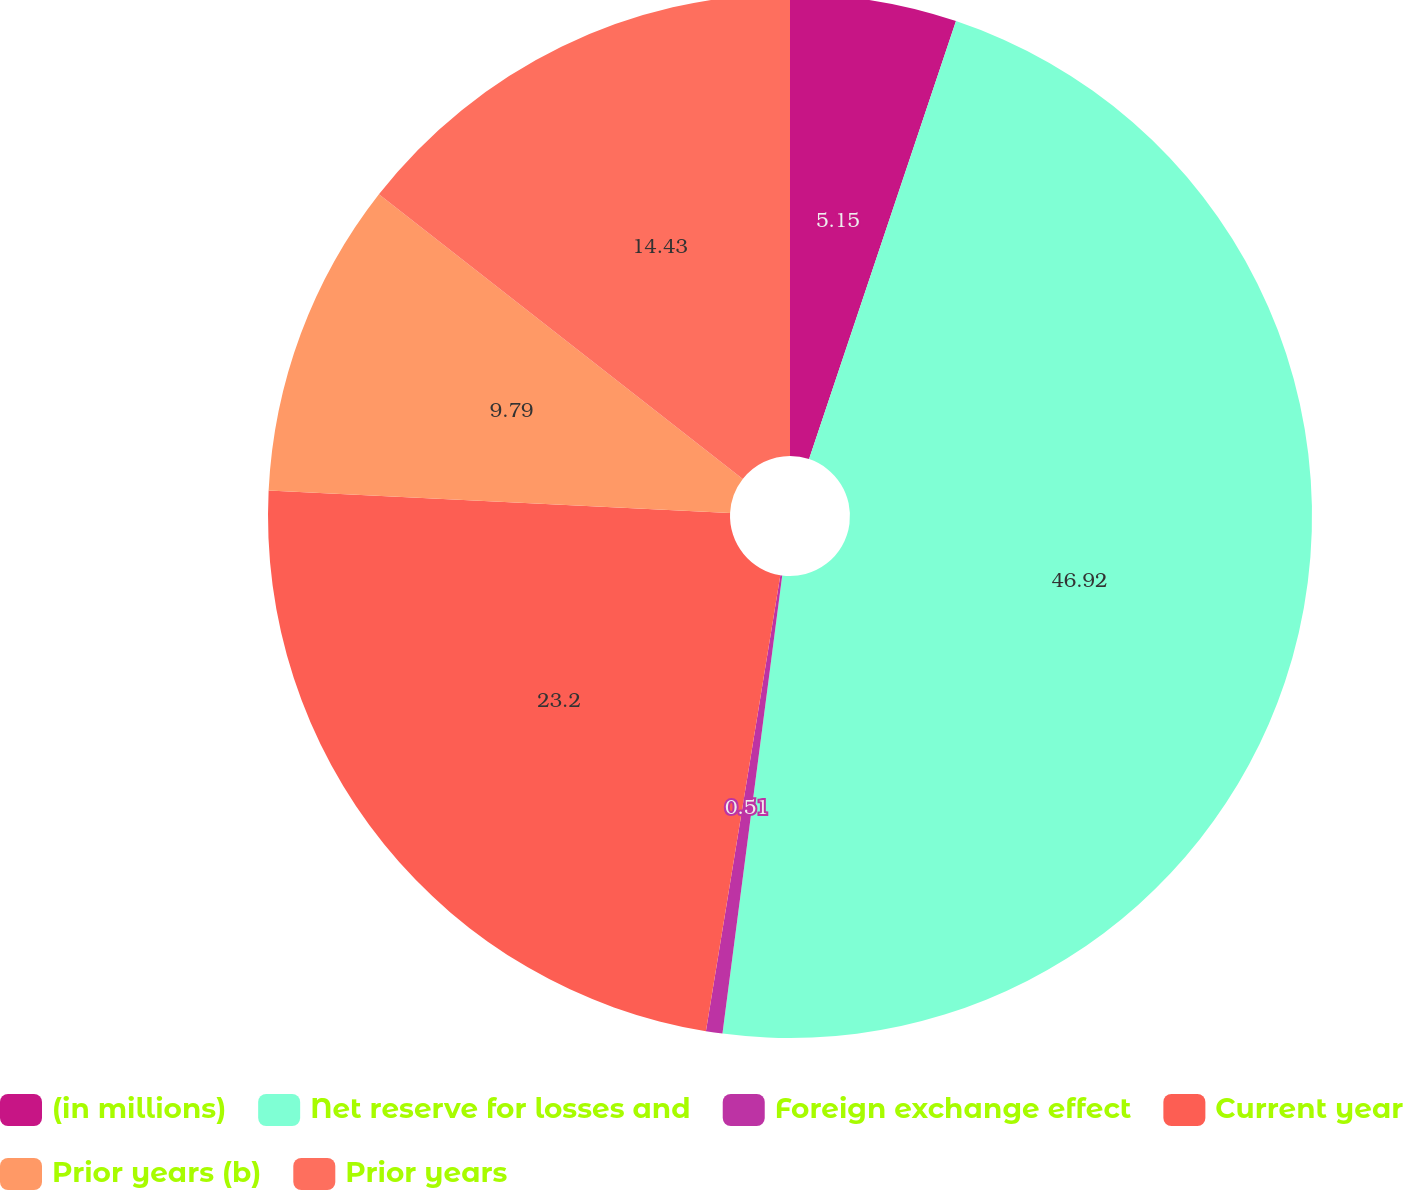Convert chart. <chart><loc_0><loc_0><loc_500><loc_500><pie_chart><fcel>(in millions)<fcel>Net reserve for losses and<fcel>Foreign exchange effect<fcel>Current year<fcel>Prior years (b)<fcel>Prior years<nl><fcel>5.15%<fcel>46.91%<fcel>0.51%<fcel>23.2%<fcel>9.79%<fcel>14.43%<nl></chart> 